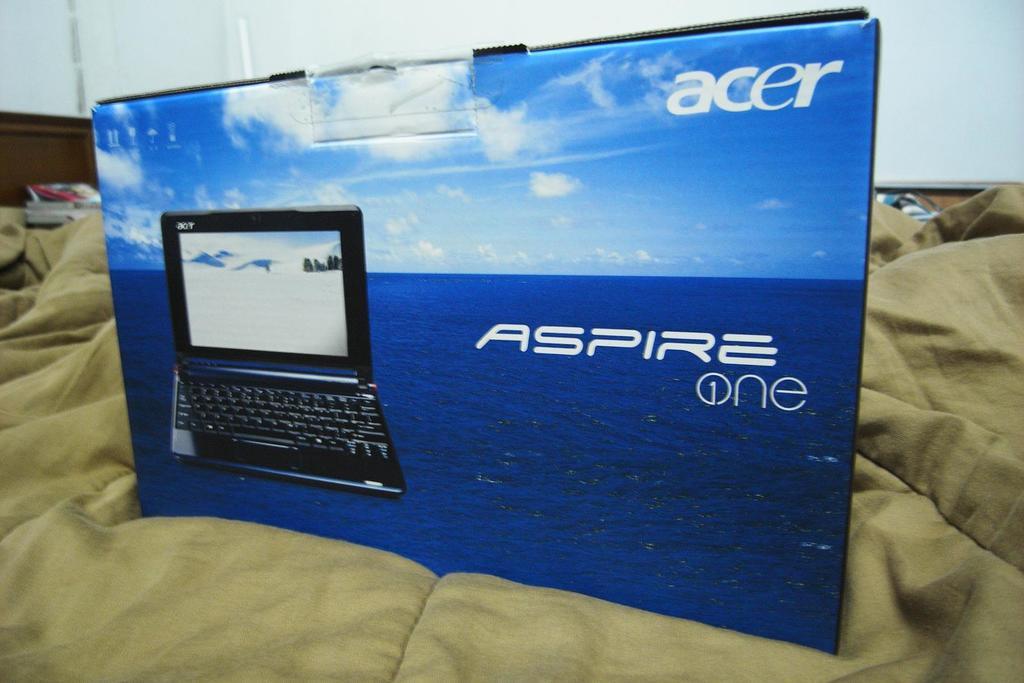What is the brand shown?
Your answer should be very brief. Acer. What brand of electronics is shown at the top right?
Make the answer very short. Acer. 